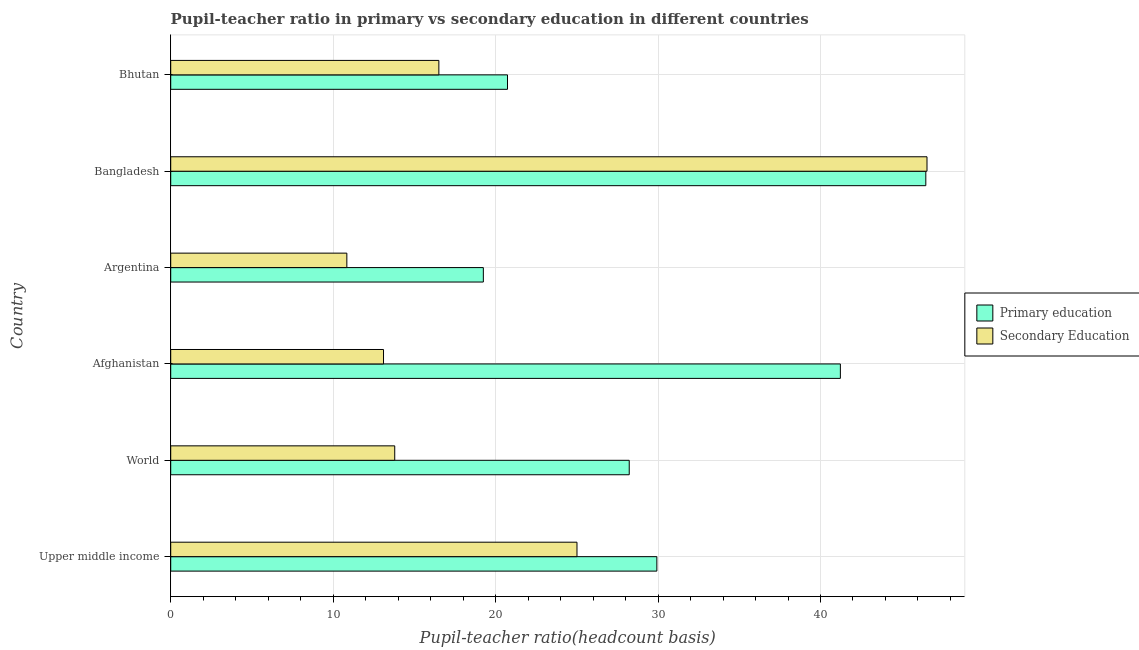How many different coloured bars are there?
Your answer should be compact. 2. Are the number of bars on each tick of the Y-axis equal?
Give a very brief answer. Yes. How many bars are there on the 3rd tick from the top?
Give a very brief answer. 2. How many bars are there on the 1st tick from the bottom?
Your response must be concise. 2. What is the label of the 4th group of bars from the top?
Offer a terse response. Afghanistan. In how many cases, is the number of bars for a given country not equal to the number of legend labels?
Your response must be concise. 0. What is the pupil-teacher ratio in primary education in Argentina?
Make the answer very short. 19.25. Across all countries, what is the maximum pupil-teacher ratio in primary education?
Provide a short and direct response. 46.48. Across all countries, what is the minimum pupil-teacher ratio in primary education?
Provide a succinct answer. 19.25. In which country was the pupil teacher ratio on secondary education maximum?
Keep it short and to the point. Bangladesh. What is the total pupil teacher ratio on secondary education in the graph?
Ensure brevity in your answer.  125.8. What is the difference between the pupil-teacher ratio in primary education in Argentina and that in World?
Your answer should be compact. -8.98. What is the difference between the pupil-teacher ratio in primary education in Bangladesh and the pupil teacher ratio on secondary education in Afghanistan?
Ensure brevity in your answer.  33.38. What is the average pupil-teacher ratio in primary education per country?
Keep it short and to the point. 30.97. What is the difference between the pupil-teacher ratio in primary education and pupil teacher ratio on secondary education in Argentina?
Give a very brief answer. 8.4. What is the ratio of the pupil-teacher ratio in primary education in Argentina to that in Bhutan?
Offer a very short reply. 0.93. What is the difference between the highest and the second highest pupil teacher ratio on secondary education?
Offer a terse response. 21.55. What is the difference between the highest and the lowest pupil-teacher ratio in primary education?
Your answer should be compact. 27.24. Is the sum of the pupil-teacher ratio in primary education in Upper middle income and World greater than the maximum pupil teacher ratio on secondary education across all countries?
Ensure brevity in your answer.  Yes. What does the 1st bar from the top in Argentina represents?
Provide a short and direct response. Secondary Education. What does the 1st bar from the bottom in Bangladesh represents?
Offer a terse response. Primary education. How many bars are there?
Keep it short and to the point. 12. Are all the bars in the graph horizontal?
Make the answer very short. Yes. Does the graph contain any zero values?
Make the answer very short. No. Does the graph contain grids?
Ensure brevity in your answer.  Yes. Where does the legend appear in the graph?
Keep it short and to the point. Center right. How are the legend labels stacked?
Your answer should be very brief. Vertical. What is the title of the graph?
Make the answer very short. Pupil-teacher ratio in primary vs secondary education in different countries. What is the label or title of the X-axis?
Offer a terse response. Pupil-teacher ratio(headcount basis). What is the label or title of the Y-axis?
Your answer should be compact. Country. What is the Pupil-teacher ratio(headcount basis) in Primary education in Upper middle income?
Offer a terse response. 29.93. What is the Pupil-teacher ratio(headcount basis) of Secondary Education in Upper middle income?
Offer a terse response. 25.01. What is the Pupil-teacher ratio(headcount basis) in Primary education in World?
Make the answer very short. 28.23. What is the Pupil-teacher ratio(headcount basis) of Secondary Education in World?
Make the answer very short. 13.79. What is the Pupil-teacher ratio(headcount basis) of Primary education in Afghanistan?
Your response must be concise. 41.22. What is the Pupil-teacher ratio(headcount basis) of Secondary Education in Afghanistan?
Your answer should be compact. 13.1. What is the Pupil-teacher ratio(headcount basis) of Primary education in Argentina?
Offer a very short reply. 19.25. What is the Pupil-teacher ratio(headcount basis) of Secondary Education in Argentina?
Ensure brevity in your answer.  10.84. What is the Pupil-teacher ratio(headcount basis) in Primary education in Bangladesh?
Keep it short and to the point. 46.48. What is the Pupil-teacher ratio(headcount basis) of Secondary Education in Bangladesh?
Your answer should be compact. 46.56. What is the Pupil-teacher ratio(headcount basis) of Primary education in Bhutan?
Your answer should be very brief. 20.73. What is the Pupil-teacher ratio(headcount basis) in Secondary Education in Bhutan?
Ensure brevity in your answer.  16.51. Across all countries, what is the maximum Pupil-teacher ratio(headcount basis) in Primary education?
Your answer should be compact. 46.48. Across all countries, what is the maximum Pupil-teacher ratio(headcount basis) of Secondary Education?
Offer a terse response. 46.56. Across all countries, what is the minimum Pupil-teacher ratio(headcount basis) in Primary education?
Your answer should be compact. 19.25. Across all countries, what is the minimum Pupil-teacher ratio(headcount basis) in Secondary Education?
Ensure brevity in your answer.  10.84. What is the total Pupil-teacher ratio(headcount basis) of Primary education in the graph?
Provide a short and direct response. 185.84. What is the total Pupil-teacher ratio(headcount basis) in Secondary Education in the graph?
Your answer should be very brief. 125.8. What is the difference between the Pupil-teacher ratio(headcount basis) of Primary education in Upper middle income and that in World?
Make the answer very short. 1.7. What is the difference between the Pupil-teacher ratio(headcount basis) of Secondary Education in Upper middle income and that in World?
Offer a terse response. 11.22. What is the difference between the Pupil-teacher ratio(headcount basis) of Primary education in Upper middle income and that in Afghanistan?
Keep it short and to the point. -11.3. What is the difference between the Pupil-teacher ratio(headcount basis) of Secondary Education in Upper middle income and that in Afghanistan?
Offer a terse response. 11.91. What is the difference between the Pupil-teacher ratio(headcount basis) in Primary education in Upper middle income and that in Argentina?
Offer a very short reply. 10.68. What is the difference between the Pupil-teacher ratio(headcount basis) in Secondary Education in Upper middle income and that in Argentina?
Offer a terse response. 14.17. What is the difference between the Pupil-teacher ratio(headcount basis) of Primary education in Upper middle income and that in Bangladesh?
Offer a very short reply. -16.56. What is the difference between the Pupil-teacher ratio(headcount basis) in Secondary Education in Upper middle income and that in Bangladesh?
Offer a terse response. -21.55. What is the difference between the Pupil-teacher ratio(headcount basis) of Primary education in Upper middle income and that in Bhutan?
Make the answer very short. 9.19. What is the difference between the Pupil-teacher ratio(headcount basis) of Secondary Education in Upper middle income and that in Bhutan?
Give a very brief answer. 8.5. What is the difference between the Pupil-teacher ratio(headcount basis) of Primary education in World and that in Afghanistan?
Make the answer very short. -13. What is the difference between the Pupil-teacher ratio(headcount basis) in Secondary Education in World and that in Afghanistan?
Offer a very short reply. 0.69. What is the difference between the Pupil-teacher ratio(headcount basis) of Primary education in World and that in Argentina?
Your answer should be compact. 8.98. What is the difference between the Pupil-teacher ratio(headcount basis) in Secondary Education in World and that in Argentina?
Provide a short and direct response. 2.95. What is the difference between the Pupil-teacher ratio(headcount basis) of Primary education in World and that in Bangladesh?
Make the answer very short. -18.26. What is the difference between the Pupil-teacher ratio(headcount basis) in Secondary Education in World and that in Bangladesh?
Your response must be concise. -32.77. What is the difference between the Pupil-teacher ratio(headcount basis) of Primary education in World and that in Bhutan?
Make the answer very short. 7.49. What is the difference between the Pupil-teacher ratio(headcount basis) of Secondary Education in World and that in Bhutan?
Your answer should be very brief. -2.72. What is the difference between the Pupil-teacher ratio(headcount basis) in Primary education in Afghanistan and that in Argentina?
Offer a terse response. 21.98. What is the difference between the Pupil-teacher ratio(headcount basis) of Secondary Education in Afghanistan and that in Argentina?
Provide a short and direct response. 2.26. What is the difference between the Pupil-teacher ratio(headcount basis) in Primary education in Afghanistan and that in Bangladesh?
Keep it short and to the point. -5.26. What is the difference between the Pupil-teacher ratio(headcount basis) of Secondary Education in Afghanistan and that in Bangladesh?
Your answer should be compact. -33.46. What is the difference between the Pupil-teacher ratio(headcount basis) in Primary education in Afghanistan and that in Bhutan?
Offer a very short reply. 20.49. What is the difference between the Pupil-teacher ratio(headcount basis) of Secondary Education in Afghanistan and that in Bhutan?
Your answer should be compact. -3.41. What is the difference between the Pupil-teacher ratio(headcount basis) of Primary education in Argentina and that in Bangladesh?
Keep it short and to the point. -27.24. What is the difference between the Pupil-teacher ratio(headcount basis) in Secondary Education in Argentina and that in Bangladesh?
Make the answer very short. -35.71. What is the difference between the Pupil-teacher ratio(headcount basis) of Primary education in Argentina and that in Bhutan?
Provide a succinct answer. -1.49. What is the difference between the Pupil-teacher ratio(headcount basis) in Secondary Education in Argentina and that in Bhutan?
Ensure brevity in your answer.  -5.66. What is the difference between the Pupil-teacher ratio(headcount basis) in Primary education in Bangladesh and that in Bhutan?
Make the answer very short. 25.75. What is the difference between the Pupil-teacher ratio(headcount basis) in Secondary Education in Bangladesh and that in Bhutan?
Offer a terse response. 30.05. What is the difference between the Pupil-teacher ratio(headcount basis) of Primary education in Upper middle income and the Pupil-teacher ratio(headcount basis) of Secondary Education in World?
Give a very brief answer. 16.14. What is the difference between the Pupil-teacher ratio(headcount basis) of Primary education in Upper middle income and the Pupil-teacher ratio(headcount basis) of Secondary Education in Afghanistan?
Your response must be concise. 16.83. What is the difference between the Pupil-teacher ratio(headcount basis) in Primary education in Upper middle income and the Pupil-teacher ratio(headcount basis) in Secondary Education in Argentina?
Offer a very short reply. 19.08. What is the difference between the Pupil-teacher ratio(headcount basis) of Primary education in Upper middle income and the Pupil-teacher ratio(headcount basis) of Secondary Education in Bangladesh?
Give a very brief answer. -16.63. What is the difference between the Pupil-teacher ratio(headcount basis) of Primary education in Upper middle income and the Pupil-teacher ratio(headcount basis) of Secondary Education in Bhutan?
Make the answer very short. 13.42. What is the difference between the Pupil-teacher ratio(headcount basis) in Primary education in World and the Pupil-teacher ratio(headcount basis) in Secondary Education in Afghanistan?
Provide a succinct answer. 15.13. What is the difference between the Pupil-teacher ratio(headcount basis) of Primary education in World and the Pupil-teacher ratio(headcount basis) of Secondary Education in Argentina?
Ensure brevity in your answer.  17.38. What is the difference between the Pupil-teacher ratio(headcount basis) in Primary education in World and the Pupil-teacher ratio(headcount basis) in Secondary Education in Bangladesh?
Offer a terse response. -18.33. What is the difference between the Pupil-teacher ratio(headcount basis) of Primary education in World and the Pupil-teacher ratio(headcount basis) of Secondary Education in Bhutan?
Ensure brevity in your answer.  11.72. What is the difference between the Pupil-teacher ratio(headcount basis) in Primary education in Afghanistan and the Pupil-teacher ratio(headcount basis) in Secondary Education in Argentina?
Ensure brevity in your answer.  30.38. What is the difference between the Pupil-teacher ratio(headcount basis) of Primary education in Afghanistan and the Pupil-teacher ratio(headcount basis) of Secondary Education in Bangladesh?
Your response must be concise. -5.33. What is the difference between the Pupil-teacher ratio(headcount basis) in Primary education in Afghanistan and the Pupil-teacher ratio(headcount basis) in Secondary Education in Bhutan?
Provide a short and direct response. 24.72. What is the difference between the Pupil-teacher ratio(headcount basis) of Primary education in Argentina and the Pupil-teacher ratio(headcount basis) of Secondary Education in Bangladesh?
Keep it short and to the point. -27.31. What is the difference between the Pupil-teacher ratio(headcount basis) in Primary education in Argentina and the Pupil-teacher ratio(headcount basis) in Secondary Education in Bhutan?
Your answer should be very brief. 2.74. What is the difference between the Pupil-teacher ratio(headcount basis) in Primary education in Bangladesh and the Pupil-teacher ratio(headcount basis) in Secondary Education in Bhutan?
Make the answer very short. 29.98. What is the average Pupil-teacher ratio(headcount basis) in Primary education per country?
Ensure brevity in your answer.  30.97. What is the average Pupil-teacher ratio(headcount basis) in Secondary Education per country?
Provide a succinct answer. 20.97. What is the difference between the Pupil-teacher ratio(headcount basis) in Primary education and Pupil-teacher ratio(headcount basis) in Secondary Education in Upper middle income?
Your answer should be compact. 4.92. What is the difference between the Pupil-teacher ratio(headcount basis) in Primary education and Pupil-teacher ratio(headcount basis) in Secondary Education in World?
Offer a very short reply. 14.44. What is the difference between the Pupil-teacher ratio(headcount basis) in Primary education and Pupil-teacher ratio(headcount basis) in Secondary Education in Afghanistan?
Ensure brevity in your answer.  28.12. What is the difference between the Pupil-teacher ratio(headcount basis) in Primary education and Pupil-teacher ratio(headcount basis) in Secondary Education in Argentina?
Offer a terse response. 8.4. What is the difference between the Pupil-teacher ratio(headcount basis) in Primary education and Pupil-teacher ratio(headcount basis) in Secondary Education in Bangladesh?
Ensure brevity in your answer.  -0.07. What is the difference between the Pupil-teacher ratio(headcount basis) of Primary education and Pupil-teacher ratio(headcount basis) of Secondary Education in Bhutan?
Provide a short and direct response. 4.22. What is the ratio of the Pupil-teacher ratio(headcount basis) of Primary education in Upper middle income to that in World?
Offer a terse response. 1.06. What is the ratio of the Pupil-teacher ratio(headcount basis) of Secondary Education in Upper middle income to that in World?
Offer a very short reply. 1.81. What is the ratio of the Pupil-teacher ratio(headcount basis) of Primary education in Upper middle income to that in Afghanistan?
Provide a short and direct response. 0.73. What is the ratio of the Pupil-teacher ratio(headcount basis) of Secondary Education in Upper middle income to that in Afghanistan?
Your response must be concise. 1.91. What is the ratio of the Pupil-teacher ratio(headcount basis) in Primary education in Upper middle income to that in Argentina?
Your response must be concise. 1.55. What is the ratio of the Pupil-teacher ratio(headcount basis) in Secondary Education in Upper middle income to that in Argentina?
Give a very brief answer. 2.31. What is the ratio of the Pupil-teacher ratio(headcount basis) in Primary education in Upper middle income to that in Bangladesh?
Offer a terse response. 0.64. What is the ratio of the Pupil-teacher ratio(headcount basis) of Secondary Education in Upper middle income to that in Bangladesh?
Offer a terse response. 0.54. What is the ratio of the Pupil-teacher ratio(headcount basis) of Primary education in Upper middle income to that in Bhutan?
Your response must be concise. 1.44. What is the ratio of the Pupil-teacher ratio(headcount basis) of Secondary Education in Upper middle income to that in Bhutan?
Make the answer very short. 1.52. What is the ratio of the Pupil-teacher ratio(headcount basis) of Primary education in World to that in Afghanistan?
Your response must be concise. 0.68. What is the ratio of the Pupil-teacher ratio(headcount basis) of Secondary Education in World to that in Afghanistan?
Offer a terse response. 1.05. What is the ratio of the Pupil-teacher ratio(headcount basis) in Primary education in World to that in Argentina?
Keep it short and to the point. 1.47. What is the ratio of the Pupil-teacher ratio(headcount basis) of Secondary Education in World to that in Argentina?
Make the answer very short. 1.27. What is the ratio of the Pupil-teacher ratio(headcount basis) of Primary education in World to that in Bangladesh?
Your answer should be very brief. 0.61. What is the ratio of the Pupil-teacher ratio(headcount basis) in Secondary Education in World to that in Bangladesh?
Provide a short and direct response. 0.3. What is the ratio of the Pupil-teacher ratio(headcount basis) in Primary education in World to that in Bhutan?
Provide a short and direct response. 1.36. What is the ratio of the Pupil-teacher ratio(headcount basis) of Secondary Education in World to that in Bhutan?
Give a very brief answer. 0.84. What is the ratio of the Pupil-teacher ratio(headcount basis) in Primary education in Afghanistan to that in Argentina?
Your answer should be compact. 2.14. What is the ratio of the Pupil-teacher ratio(headcount basis) of Secondary Education in Afghanistan to that in Argentina?
Keep it short and to the point. 1.21. What is the ratio of the Pupil-teacher ratio(headcount basis) in Primary education in Afghanistan to that in Bangladesh?
Your response must be concise. 0.89. What is the ratio of the Pupil-teacher ratio(headcount basis) in Secondary Education in Afghanistan to that in Bangladesh?
Ensure brevity in your answer.  0.28. What is the ratio of the Pupil-teacher ratio(headcount basis) in Primary education in Afghanistan to that in Bhutan?
Your answer should be very brief. 1.99. What is the ratio of the Pupil-teacher ratio(headcount basis) in Secondary Education in Afghanistan to that in Bhutan?
Make the answer very short. 0.79. What is the ratio of the Pupil-teacher ratio(headcount basis) in Primary education in Argentina to that in Bangladesh?
Provide a succinct answer. 0.41. What is the ratio of the Pupil-teacher ratio(headcount basis) of Secondary Education in Argentina to that in Bangladesh?
Offer a very short reply. 0.23. What is the ratio of the Pupil-teacher ratio(headcount basis) in Primary education in Argentina to that in Bhutan?
Ensure brevity in your answer.  0.93. What is the ratio of the Pupil-teacher ratio(headcount basis) in Secondary Education in Argentina to that in Bhutan?
Provide a short and direct response. 0.66. What is the ratio of the Pupil-teacher ratio(headcount basis) in Primary education in Bangladesh to that in Bhutan?
Your response must be concise. 2.24. What is the ratio of the Pupil-teacher ratio(headcount basis) of Secondary Education in Bangladesh to that in Bhutan?
Give a very brief answer. 2.82. What is the difference between the highest and the second highest Pupil-teacher ratio(headcount basis) in Primary education?
Your response must be concise. 5.26. What is the difference between the highest and the second highest Pupil-teacher ratio(headcount basis) in Secondary Education?
Your response must be concise. 21.55. What is the difference between the highest and the lowest Pupil-teacher ratio(headcount basis) in Primary education?
Ensure brevity in your answer.  27.24. What is the difference between the highest and the lowest Pupil-teacher ratio(headcount basis) in Secondary Education?
Give a very brief answer. 35.71. 